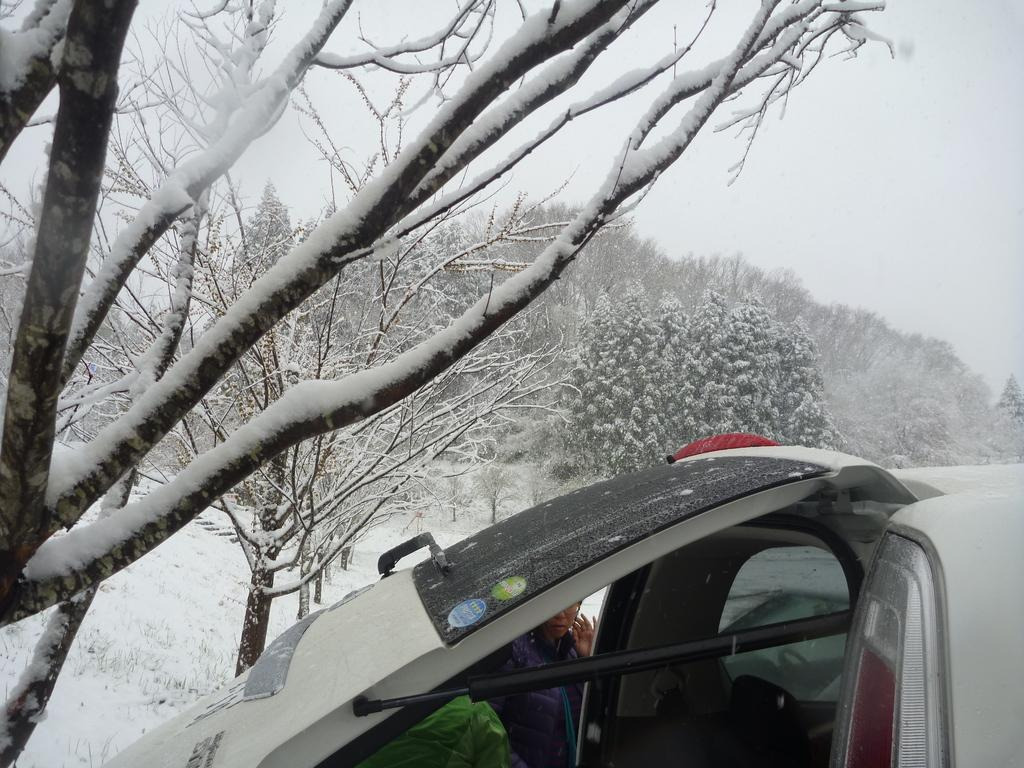What is located in the center of the image? There are trees in the center of the image. What type of weather is depicted in the image? There is snow in the image, indicating cold weather. What type of animal can be seen in the image? There is a cat in the image. Can you describe the person in the image? There is a person in the image, but their specific appearance or actions are not mentioned in the facts. What is visible in the background of the image? The sky is visible in the image. How many quince are being used to decorate the trees in the image? There is no mention of quince in the image, so it is impossible to determine if any are present or being used for decoration. Can you describe the hole that the person is digging in the image? There is no mention of a hole or any digging activity in the image. 